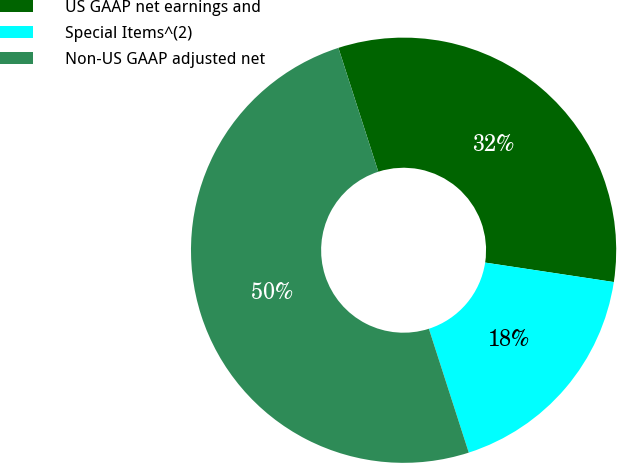<chart> <loc_0><loc_0><loc_500><loc_500><pie_chart><fcel>US GAAP net earnings and<fcel>Special Items^(2)<fcel>Non-US GAAP adjusted net<nl><fcel>32.35%<fcel>17.65%<fcel>50.0%<nl></chart> 